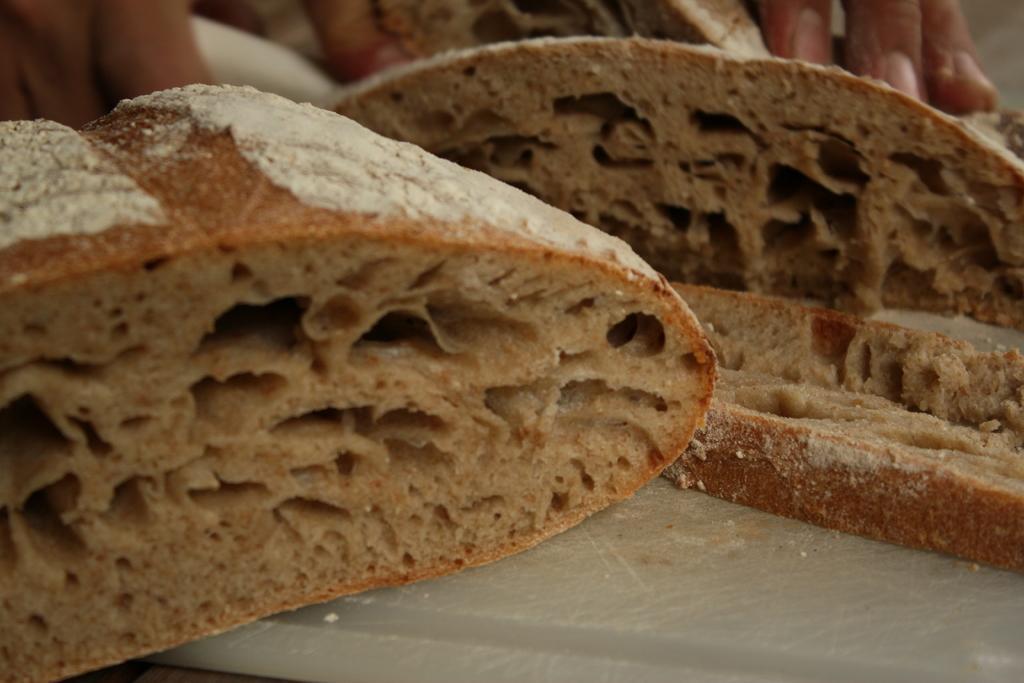Could you give a brief overview of what you see in this image? In this image I can see pieces of bread and a person's hand on the table. This image is taken in a room. 